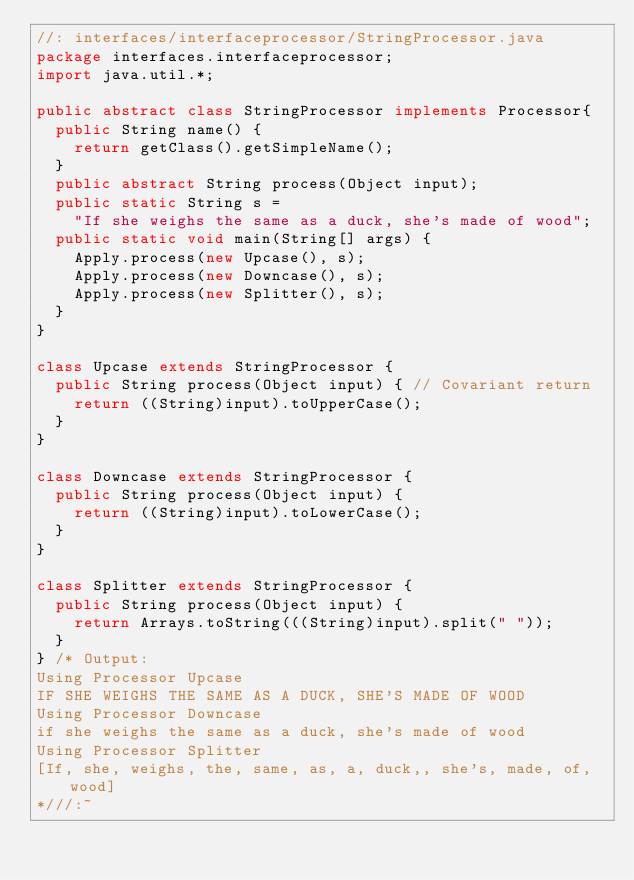Convert code to text. <code><loc_0><loc_0><loc_500><loc_500><_Java_>//: interfaces/interfaceprocessor/StringProcessor.java
package interfaces.interfaceprocessor;
import java.util.*;

public abstract class StringProcessor implements Processor{
  public String name() {
    return getClass().getSimpleName();
  }
  public abstract String process(Object input);
  public static String s =
    "If she weighs the same as a duck, she's made of wood";
  public static void main(String[] args) {
    Apply.process(new Upcase(), s);
    Apply.process(new Downcase(), s);
    Apply.process(new Splitter(), s);
  }
}	

class Upcase extends StringProcessor {
  public String process(Object input) { // Covariant return
    return ((String)input).toUpperCase();
  }
}

class Downcase extends StringProcessor {
  public String process(Object input) {
    return ((String)input).toLowerCase();
  }
}

class Splitter extends StringProcessor {
  public String process(Object input) {
    return Arrays.toString(((String)input).split(" "));
  }	
} /* Output:
Using Processor Upcase
IF SHE WEIGHS THE SAME AS A DUCK, SHE'S MADE OF WOOD
Using Processor Downcase
if she weighs the same as a duck, she's made of wood
Using Processor Splitter
[If, she, weighs, the, same, as, a, duck,, she's, made, of, wood]
*///:~
</code> 